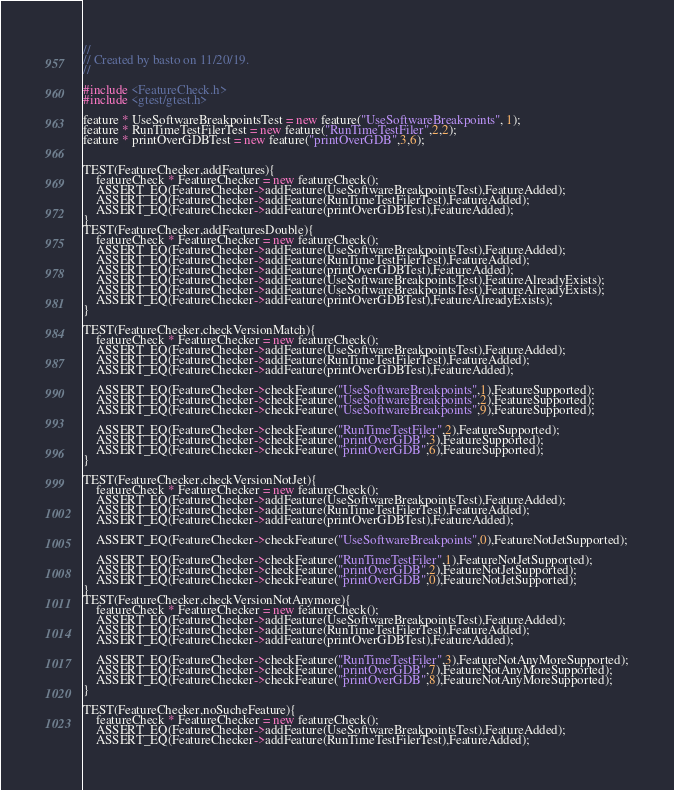<code> <loc_0><loc_0><loc_500><loc_500><_C++_>//
// Created by basto on 11/20/19.
//

#include <FeatureCheck.h>
#include <gtest/gtest.h>

feature * UseSoftwareBreakpointsTest = new feature("UseSoftwareBreakpoints", 1);
feature * RunTimeTestFilerTest = new feature("RunTimeTestFiler",2,2);
feature * printOverGDBTest = new feature("printOverGDB",3,6);


TEST(FeatureChecker,addFeatures){
    featureCheck * FeatureChecker = new featureCheck();
    ASSERT_EQ(FeatureChecker->addFeature(UseSoftwareBreakpointsTest),FeatureAdded);
    ASSERT_EQ(FeatureChecker->addFeature(RunTimeTestFilerTest),FeatureAdded);
    ASSERT_EQ(FeatureChecker->addFeature(printOverGDBTest),FeatureAdded);
}
TEST(FeatureChecker,addFeaturesDouble){
    featureCheck * FeatureChecker = new featureCheck();
    ASSERT_EQ(FeatureChecker->addFeature(UseSoftwareBreakpointsTest),FeatureAdded);
    ASSERT_EQ(FeatureChecker->addFeature(RunTimeTestFilerTest),FeatureAdded);
    ASSERT_EQ(FeatureChecker->addFeature(printOverGDBTest),FeatureAdded);
    ASSERT_EQ(FeatureChecker->addFeature(UseSoftwareBreakpointsTest),FeatureAlreadyExists);
    ASSERT_EQ(FeatureChecker->addFeature(UseSoftwareBreakpointsTest),FeatureAlreadyExists);
    ASSERT_EQ(FeatureChecker->addFeature(printOverGDBTest),FeatureAlreadyExists);
}

TEST(FeatureChecker,checkVersionMatch){
    featureCheck * FeatureChecker = new featureCheck();
    ASSERT_EQ(FeatureChecker->addFeature(UseSoftwareBreakpointsTest),FeatureAdded);
    ASSERT_EQ(FeatureChecker->addFeature(RunTimeTestFilerTest),FeatureAdded);
    ASSERT_EQ(FeatureChecker->addFeature(printOverGDBTest),FeatureAdded);

    ASSERT_EQ(FeatureChecker->checkFeature("UseSoftwareBreakpoints",1),FeatureSupported);
    ASSERT_EQ(FeatureChecker->checkFeature("UseSoftwareBreakpoints",2),FeatureSupported);
    ASSERT_EQ(FeatureChecker->checkFeature("UseSoftwareBreakpoints",9),FeatureSupported);

    ASSERT_EQ(FeatureChecker->checkFeature("RunTimeTestFiler",2),FeatureSupported);
    ASSERT_EQ(FeatureChecker->checkFeature("printOverGDB",3),FeatureSupported);
    ASSERT_EQ(FeatureChecker->checkFeature("printOverGDB",6),FeatureSupported);
}

TEST(FeatureChecker,checkVersionNotJet){
    featureCheck * FeatureChecker = new featureCheck();
    ASSERT_EQ(FeatureChecker->addFeature(UseSoftwareBreakpointsTest),FeatureAdded);
    ASSERT_EQ(FeatureChecker->addFeature(RunTimeTestFilerTest),FeatureAdded);
    ASSERT_EQ(FeatureChecker->addFeature(printOverGDBTest),FeatureAdded);

    ASSERT_EQ(FeatureChecker->checkFeature("UseSoftwareBreakpoints",0),FeatureNotJetSupported);

    ASSERT_EQ(FeatureChecker->checkFeature("RunTimeTestFiler",1),FeatureNotJetSupported);
    ASSERT_EQ(FeatureChecker->checkFeature("printOverGDB",2),FeatureNotJetSupported);
    ASSERT_EQ(FeatureChecker->checkFeature("printOverGDB",0),FeatureNotJetSupported);
}
TEST(FeatureChecker,checkVersionNotAnymore){
    featureCheck * FeatureChecker = new featureCheck();
    ASSERT_EQ(FeatureChecker->addFeature(UseSoftwareBreakpointsTest),FeatureAdded);
    ASSERT_EQ(FeatureChecker->addFeature(RunTimeTestFilerTest),FeatureAdded);
    ASSERT_EQ(FeatureChecker->addFeature(printOverGDBTest),FeatureAdded);

    ASSERT_EQ(FeatureChecker->checkFeature("RunTimeTestFiler",3),FeatureNotAnyMoreSupported);
    ASSERT_EQ(FeatureChecker->checkFeature("printOverGDB",7),FeatureNotAnyMoreSupported);
    ASSERT_EQ(FeatureChecker->checkFeature("printOverGDB",8),FeatureNotAnyMoreSupported);
}

TEST(FeatureChecker,noSucheFeature){
    featureCheck * FeatureChecker = new featureCheck();
    ASSERT_EQ(FeatureChecker->addFeature(UseSoftwareBreakpointsTest),FeatureAdded);
    ASSERT_EQ(FeatureChecker->addFeature(RunTimeTestFilerTest),FeatureAdded);</code> 